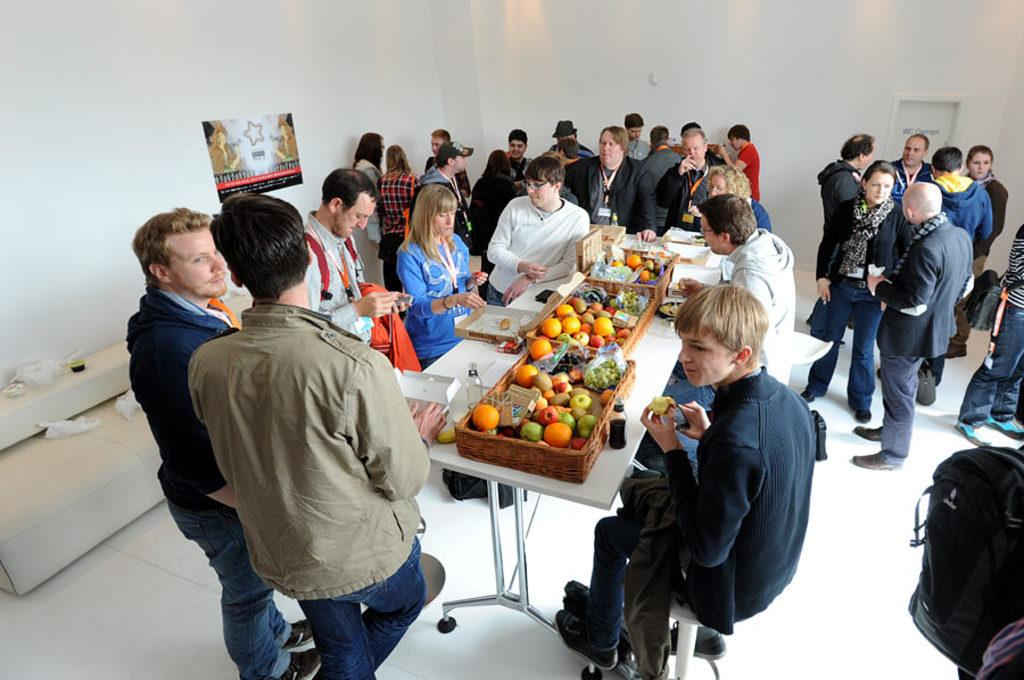How many people are in the image? There is a group of people in the image, but the exact number is not specified. What are some of the people in the image doing? Some people are seated on chairs, while others are standing. What items can be seen on the table in the image? There are fruits, bottles, and books on the table. Reasoning: Let's think step by identifying the main subjects and objects in the image based on the provided facts. We then formulate questions that focus on the actions and characteristics of these subjects and objects, ensuring that each question can be answered definitively with the information given. We avoid yes/no questions and ensure that the language is simple and clear. Absurd Question/Answer: What type of sheet is being used to answer questions in the image? There is no sheet present in the image, nor is anyone answering questions. What type of sheet is being used to answer questions in the image? There is no sheet present in the image, nor is anyone answering questions. 